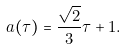<formula> <loc_0><loc_0><loc_500><loc_500>a ( \tau ) = \frac { \sqrt { 2 } } { 3 } \tau + 1 .</formula> 